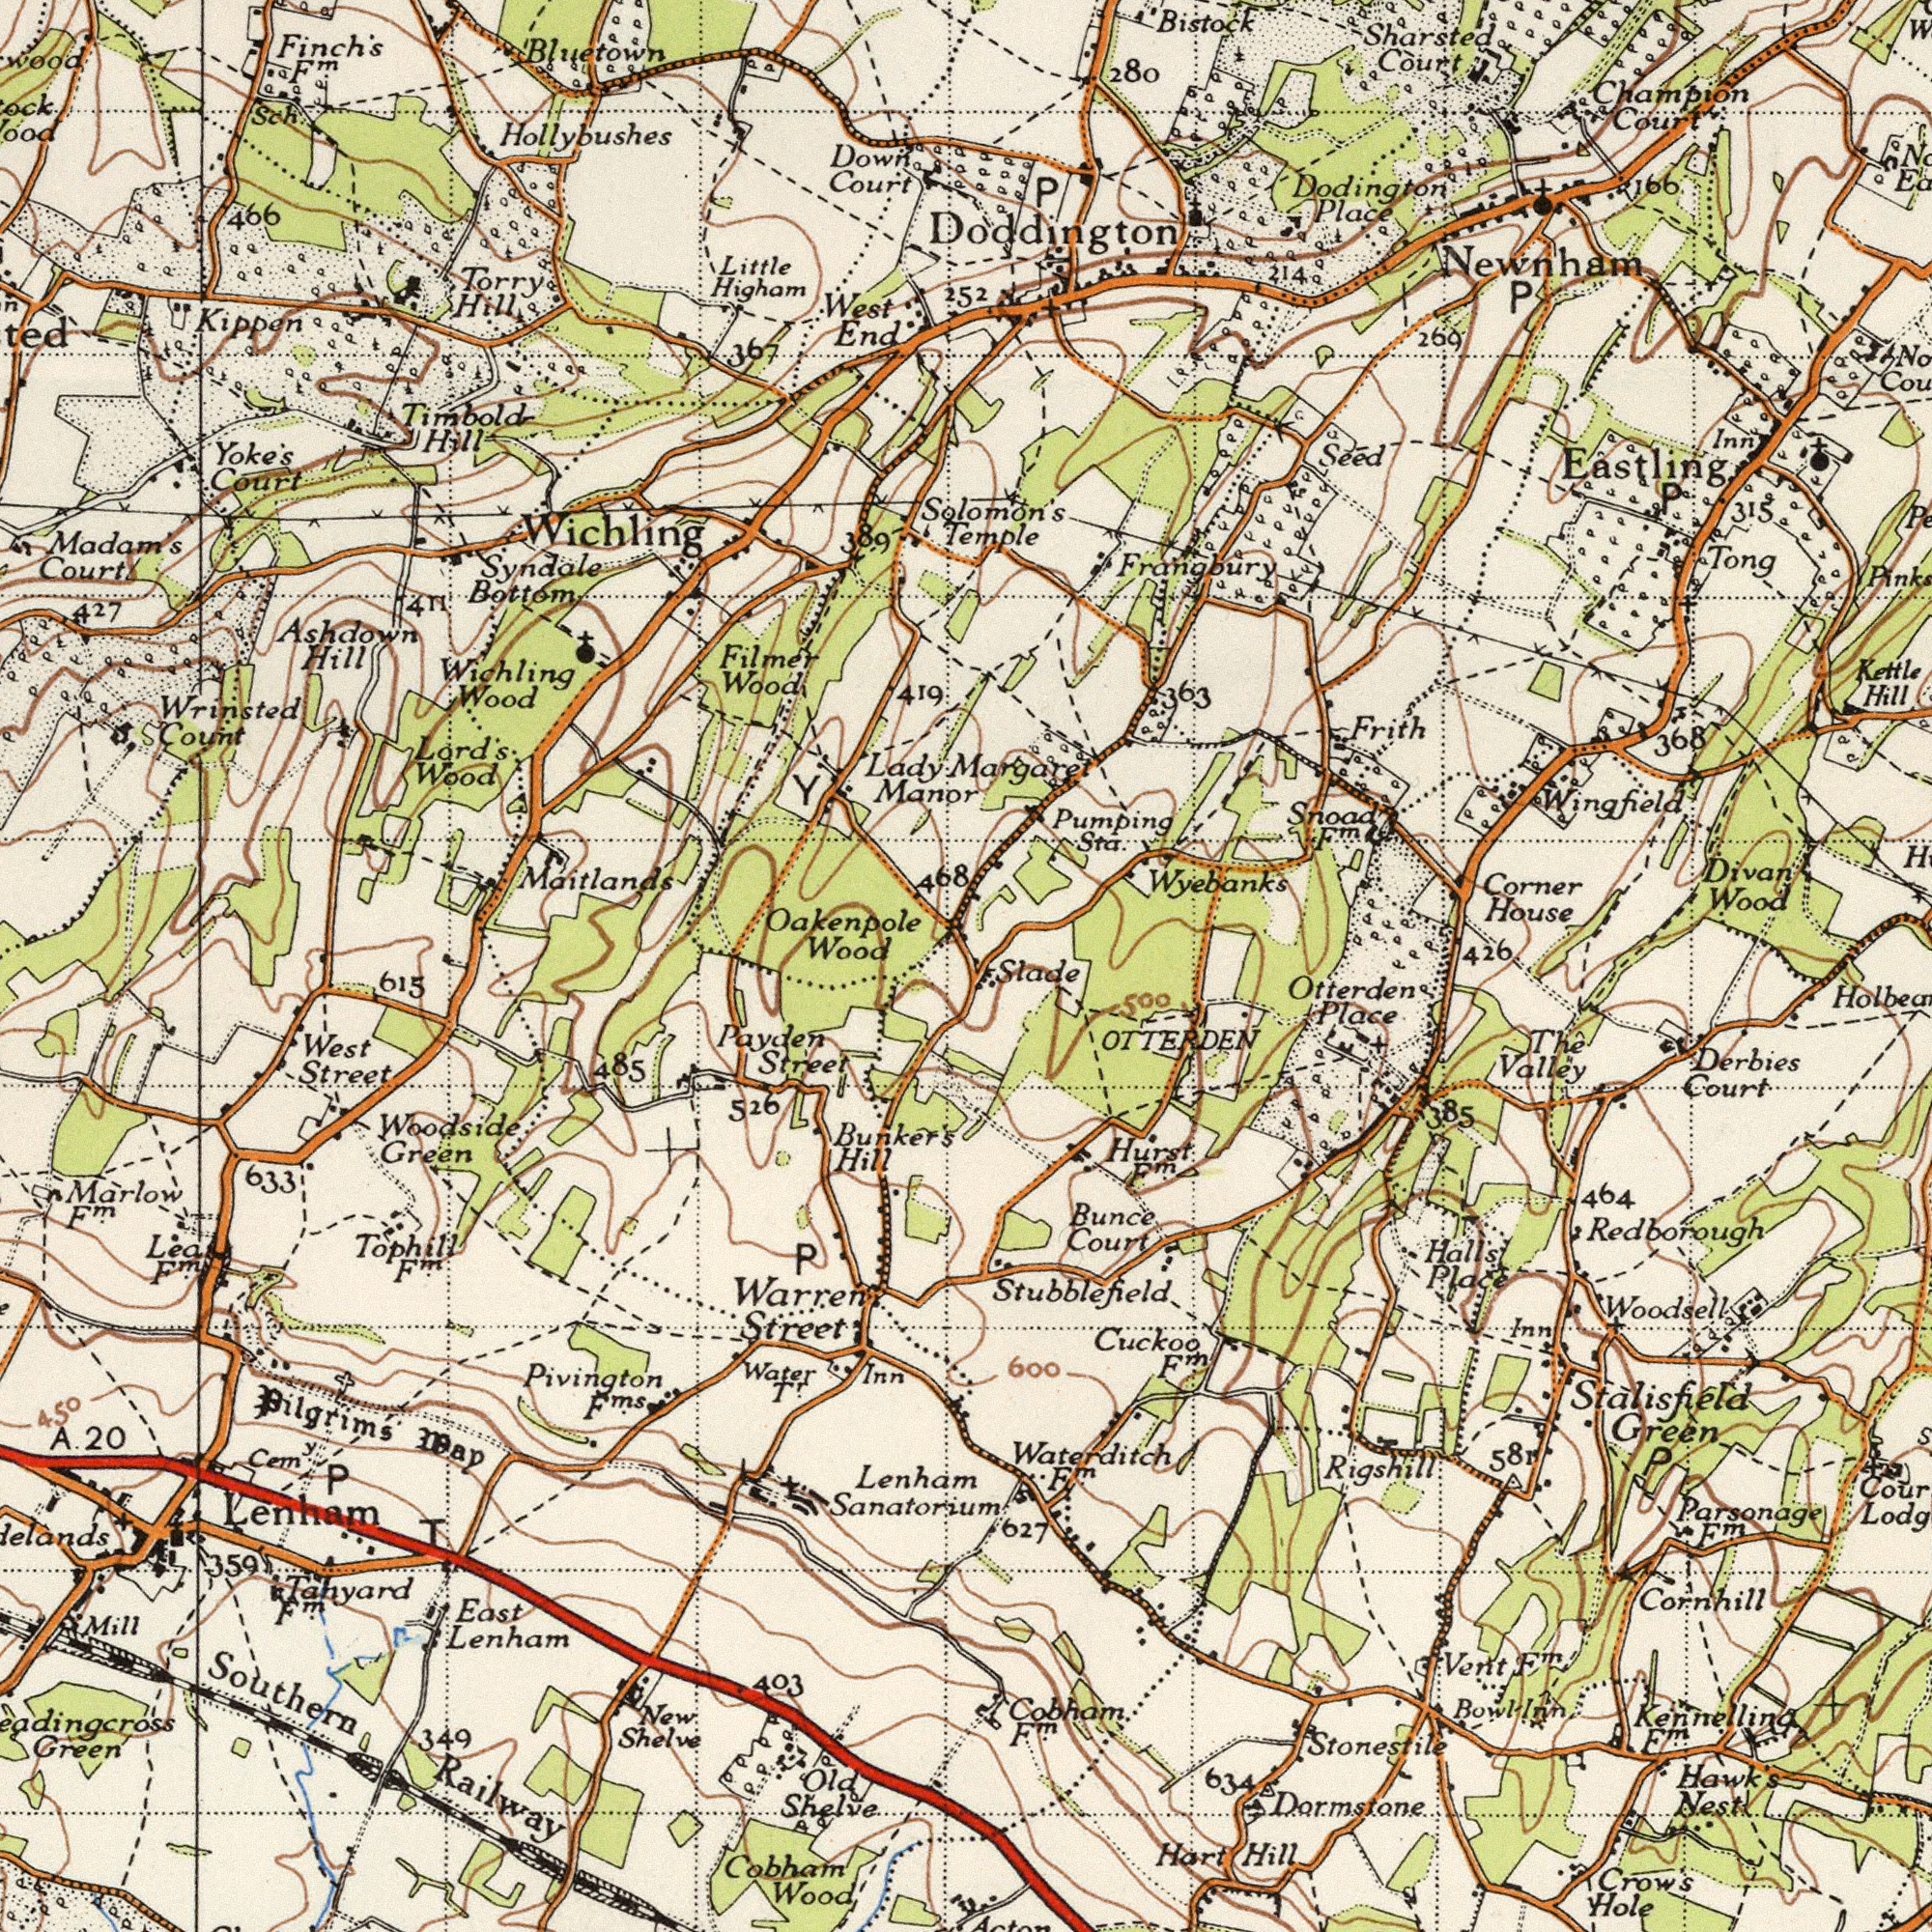What text can you see in the bottom-left section? Railway Pivington Lenham Bunker's Tahyard East Cobham Street Street 615 Pilgrims Sanatorium Green Shelve West Payden 526 Marlow Cem<sup>y</sup>. 349 Wood Shelve Water Green Hill Inn 403 Old 485 New Mill Street 450 Southern Tophill Warren Lenhanm T May 359 Woodside T<sup>r</sup>. P 633 P Lea F<sup>m</sup>. F<sup>ms</sup>. F<sup>m</sup>. Lenham F<sup>m</sup>. F<sup>m</sup>. 20 A. What text is shown in the bottom-right quadrant? Redborough Parsonage Cornhill Stalisfield Derbies Green Woodsell Crow's Otterden Hill Bunce Cuckoo Hart Valley Stonestile 464 Court Hall's Court Hawk's Dormstone Hole Inn Place Vent Hurst 634 Thê 600 581 Place Bowl F<sup>m</sup>. 385 OTTERDEN F<sup>m</sup>. Kennelling 500 627 F<sup>m</sup>. Rigshill F<sup>m</sup>. Waterditch F<sup>m</sup>. Cobham Nest Stubblefield F<sup>m</sup>. Slade F<sup>m</sup>. P Inn What text is visible in the upper-right corner? Wyebanks Newnham Wingfield House Corner Wood Place Dodington Kettle Divan Sharsted Tong 269 Hill 368 Frith Court Solomon's Inn 426 Seed 315 280 Sta. Frangbury Bistock Court Temple P 166 Eastling P 214 Snood Pumping Champion Margaret P F<sup>m</sup>. Doddington 363 What text appears in the top-left area of the image? Wichling Court Syndale West Wood Hollybushes Highom Yoke's Wood Bottom Oakenpole Maitlands End Little Court Kippen Madam's Wichling Wood Wood 466 Count 419 Manor Lord's 468 Hill Hill Court Filmer Wrinsted Down Timbold 427 Bluetown 411 Sch. Lady Finch's Hill 367 Torry Ashdown 389 F<sup>m</sup>. 252 Y 